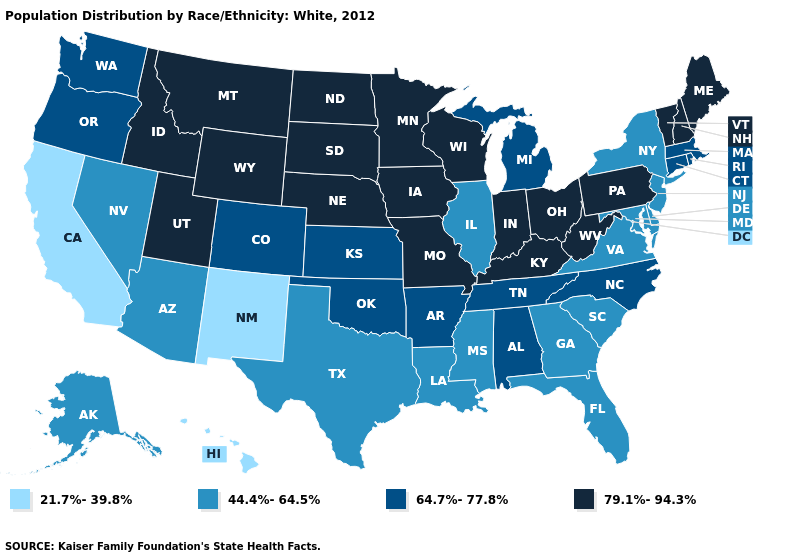Which states hav the highest value in the MidWest?
Answer briefly. Indiana, Iowa, Minnesota, Missouri, Nebraska, North Dakota, Ohio, South Dakota, Wisconsin. What is the lowest value in states that border New Hampshire?
Be succinct. 64.7%-77.8%. Does Nebraska have a higher value than Ohio?
Answer briefly. No. What is the highest value in the West ?
Give a very brief answer. 79.1%-94.3%. How many symbols are there in the legend?
Give a very brief answer. 4. What is the value of Wisconsin?
Answer briefly. 79.1%-94.3%. Name the states that have a value in the range 64.7%-77.8%?
Write a very short answer. Alabama, Arkansas, Colorado, Connecticut, Kansas, Massachusetts, Michigan, North Carolina, Oklahoma, Oregon, Rhode Island, Tennessee, Washington. Name the states that have a value in the range 21.7%-39.8%?
Concise answer only. California, Hawaii, New Mexico. What is the highest value in the USA?
Be succinct. 79.1%-94.3%. Does Michigan have a higher value than Indiana?
Keep it brief. No. Name the states that have a value in the range 64.7%-77.8%?
Keep it brief. Alabama, Arkansas, Colorado, Connecticut, Kansas, Massachusetts, Michigan, North Carolina, Oklahoma, Oregon, Rhode Island, Tennessee, Washington. What is the value of California?
Quick response, please. 21.7%-39.8%. Does Washington have the lowest value in the West?
Give a very brief answer. No. Among the states that border Alabama , does Georgia have the lowest value?
Answer briefly. Yes. Which states have the highest value in the USA?
Quick response, please. Idaho, Indiana, Iowa, Kentucky, Maine, Minnesota, Missouri, Montana, Nebraska, New Hampshire, North Dakota, Ohio, Pennsylvania, South Dakota, Utah, Vermont, West Virginia, Wisconsin, Wyoming. 